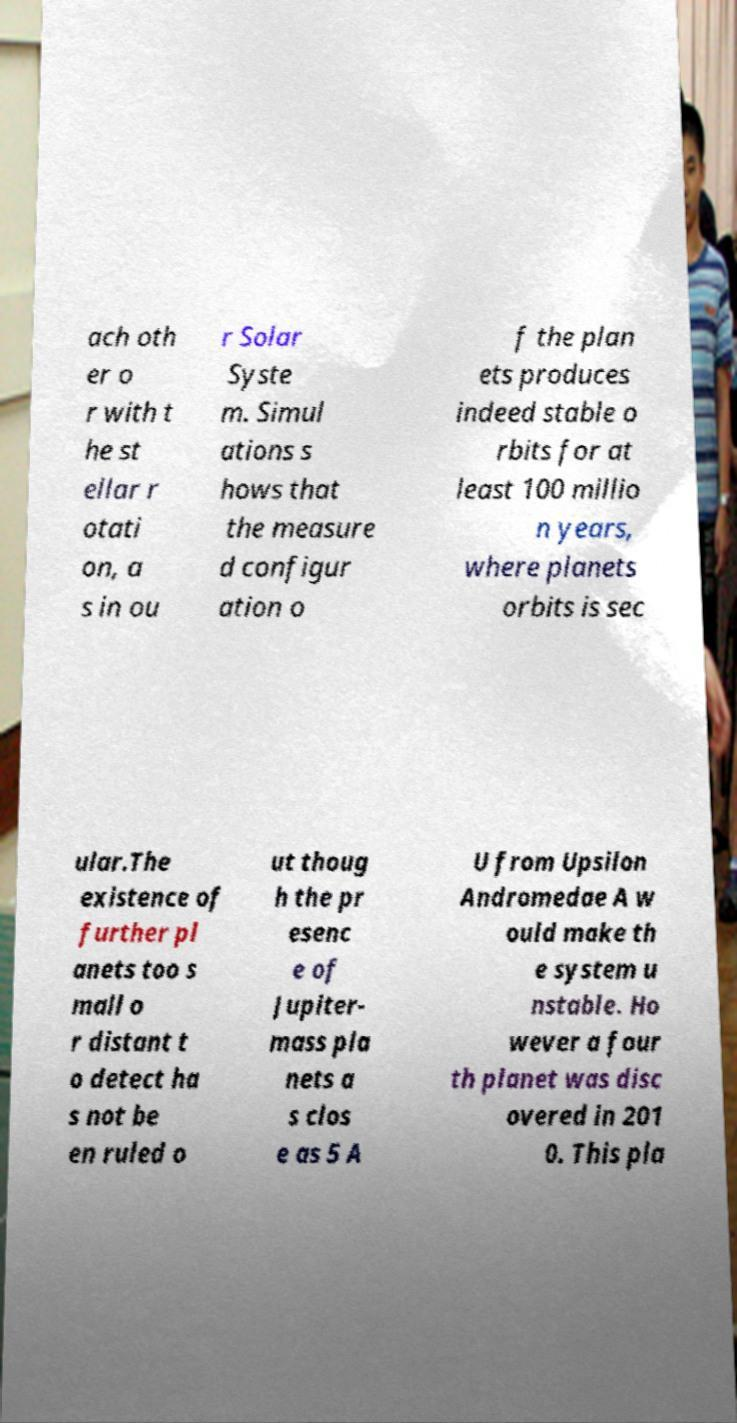There's text embedded in this image that I need extracted. Can you transcribe it verbatim? ach oth er o r with t he st ellar r otati on, a s in ou r Solar Syste m. Simul ations s hows that the measure d configur ation o f the plan ets produces indeed stable o rbits for at least 100 millio n years, where planets orbits is sec ular.The existence of further pl anets too s mall o r distant t o detect ha s not be en ruled o ut thoug h the pr esenc e of Jupiter- mass pla nets a s clos e as 5 A U from Upsilon Andromedae A w ould make th e system u nstable. Ho wever a four th planet was disc overed in 201 0. This pla 